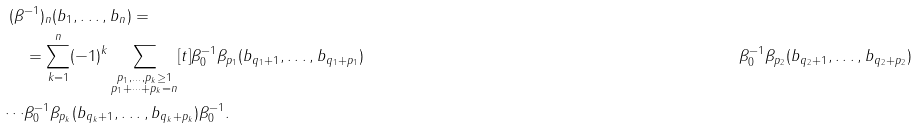<formula> <loc_0><loc_0><loc_500><loc_500>( \beta & ^ { - 1 } ) _ { n } ( b _ { 1 } , \dots , b _ { n } ) = \\ & = \sum _ { k = 1 } ^ { n } ( - 1 ) ^ { k } \sum _ { \substack { p _ { 1 } , \dots , p _ { k } \geq 1 \\ p _ { 1 } + \cdots + p _ { k } = n } } [ t ] \beta _ { 0 } ^ { - 1 } \beta _ { p _ { 1 } } ( b _ { q _ { 1 } + 1 } , \dots , b _ { q _ { 1 } + p _ { 1 } } ) & \beta _ { 0 } ^ { - 1 } \beta _ { p _ { 2 } } ( b _ { q _ { 2 } + 1 } , \dots , b _ { q _ { 2 } + p _ { 2 } } ) \\ \cdots & \beta _ { 0 } ^ { - 1 } \beta _ { p _ { k } } ( b _ { q _ { k } + 1 } , \dots , b _ { q _ { k } + p _ { k } } ) \beta _ { 0 } ^ { - 1 } .</formula> 